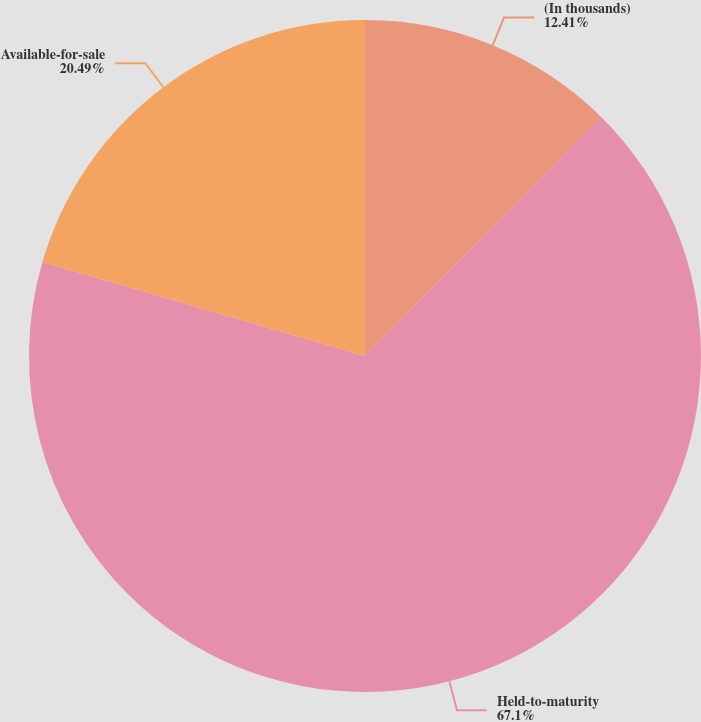Convert chart to OTSL. <chart><loc_0><loc_0><loc_500><loc_500><pie_chart><fcel>(In thousands)<fcel>Held-to-maturity<fcel>Available-for-sale<nl><fcel>12.41%<fcel>67.1%<fcel>20.49%<nl></chart> 